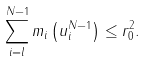<formula> <loc_0><loc_0><loc_500><loc_500>\sum _ { i = l } ^ { N - 1 } m _ { i } \left ( u _ { i } ^ { N - 1 } \right ) \leq r _ { 0 } ^ { 2 } .</formula> 